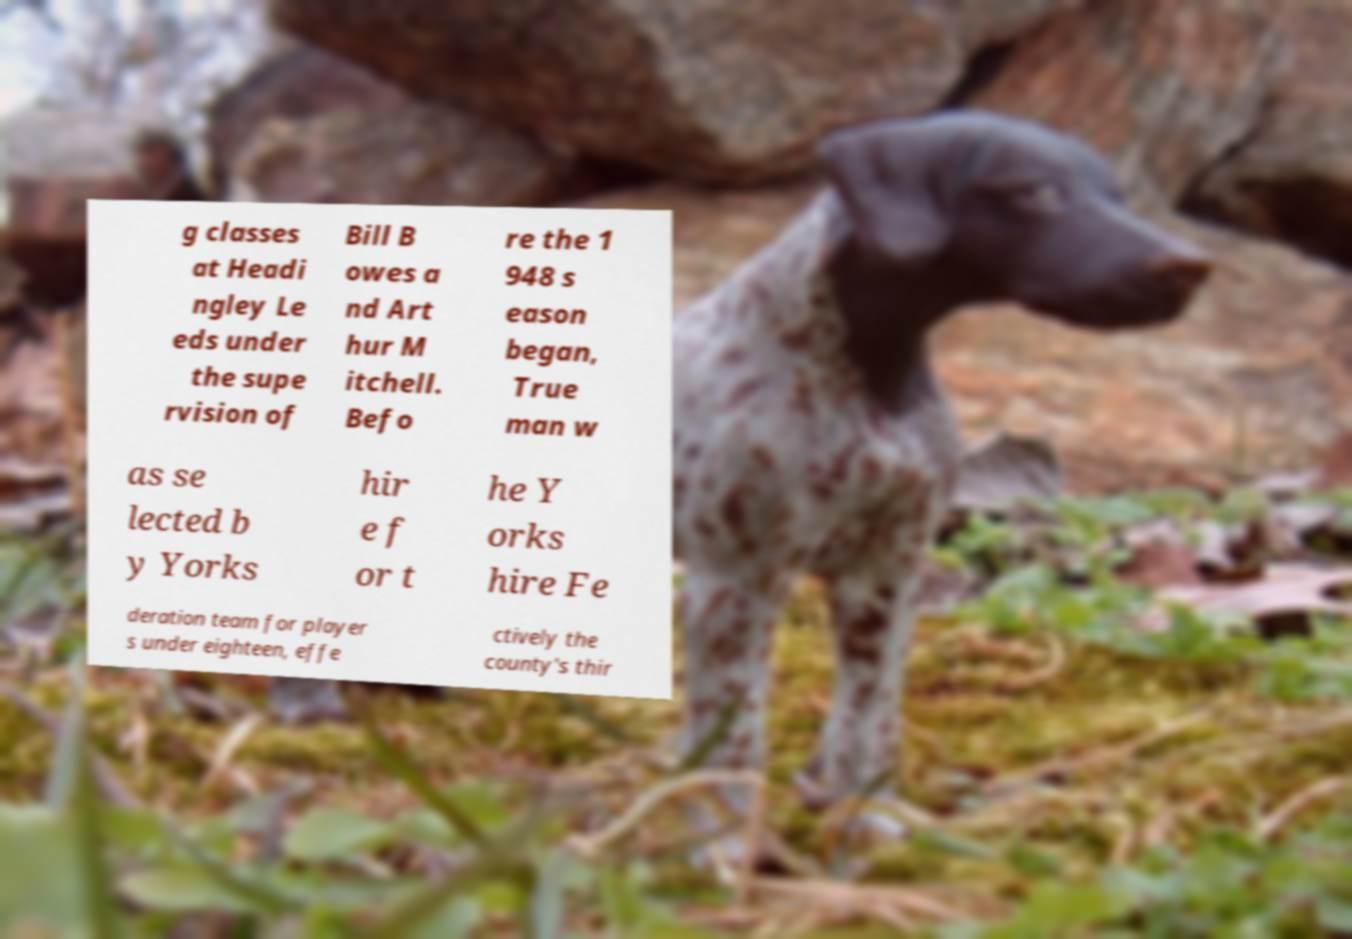For documentation purposes, I need the text within this image transcribed. Could you provide that? g classes at Headi ngley Le eds under the supe rvision of Bill B owes a nd Art hur M itchell. Befo re the 1 948 s eason began, True man w as se lected b y Yorks hir e f or t he Y orks hire Fe deration team for player s under eighteen, effe ctively the county's thir 